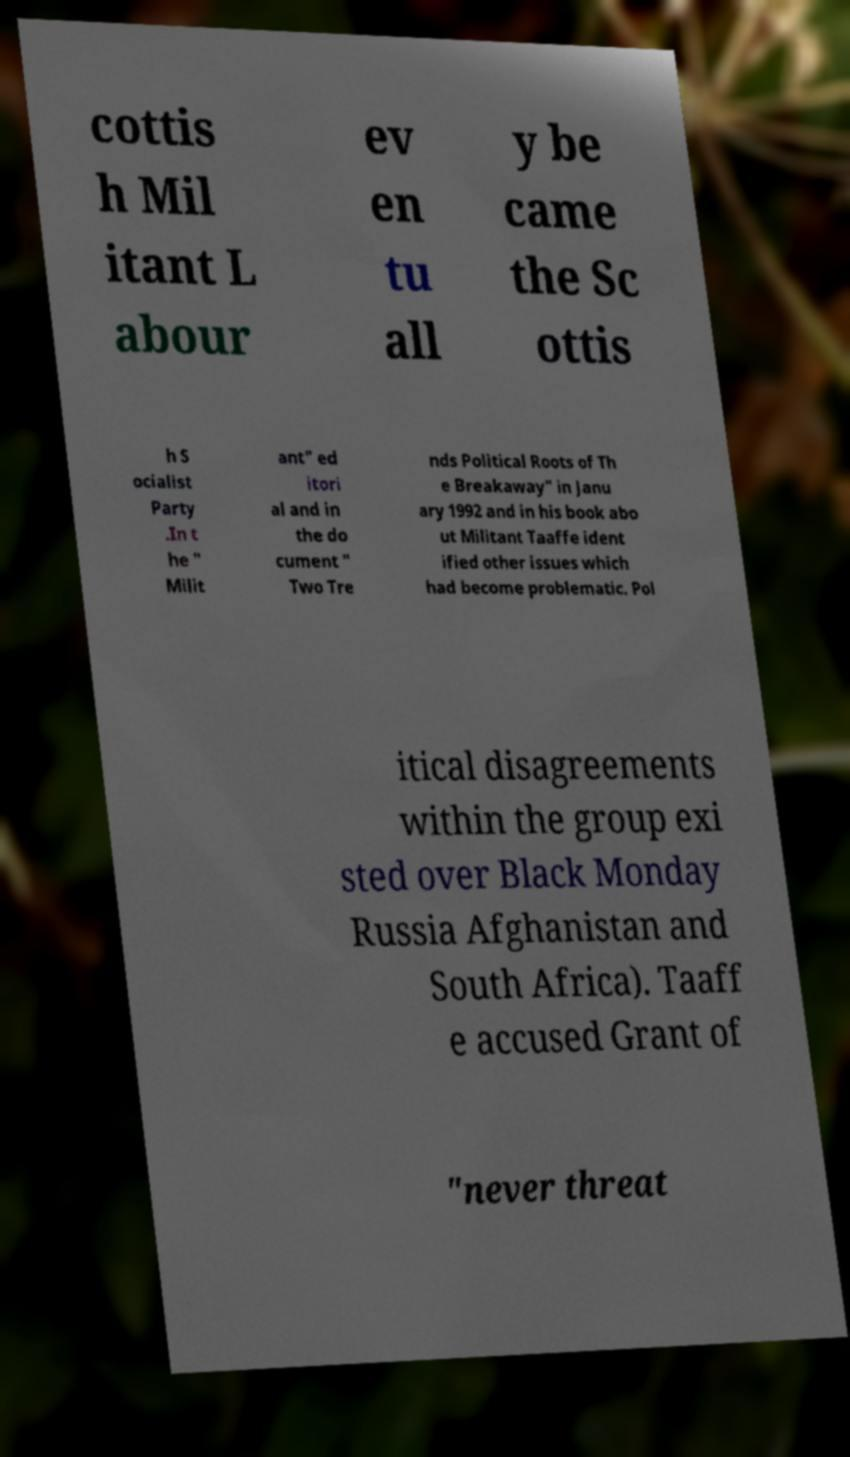Can you accurately transcribe the text from the provided image for me? cottis h Mil itant L abour ev en tu all y be came the Sc ottis h S ocialist Party .In t he " Milit ant" ed itori al and in the do cument " Two Tre nds Political Roots of Th e Breakaway" in Janu ary 1992 and in his book abo ut Militant Taaffe ident ified other issues which had become problematic. Pol itical disagreements within the group exi sted over Black Monday Russia Afghanistan and South Africa). Taaff e accused Grant of "never threat 